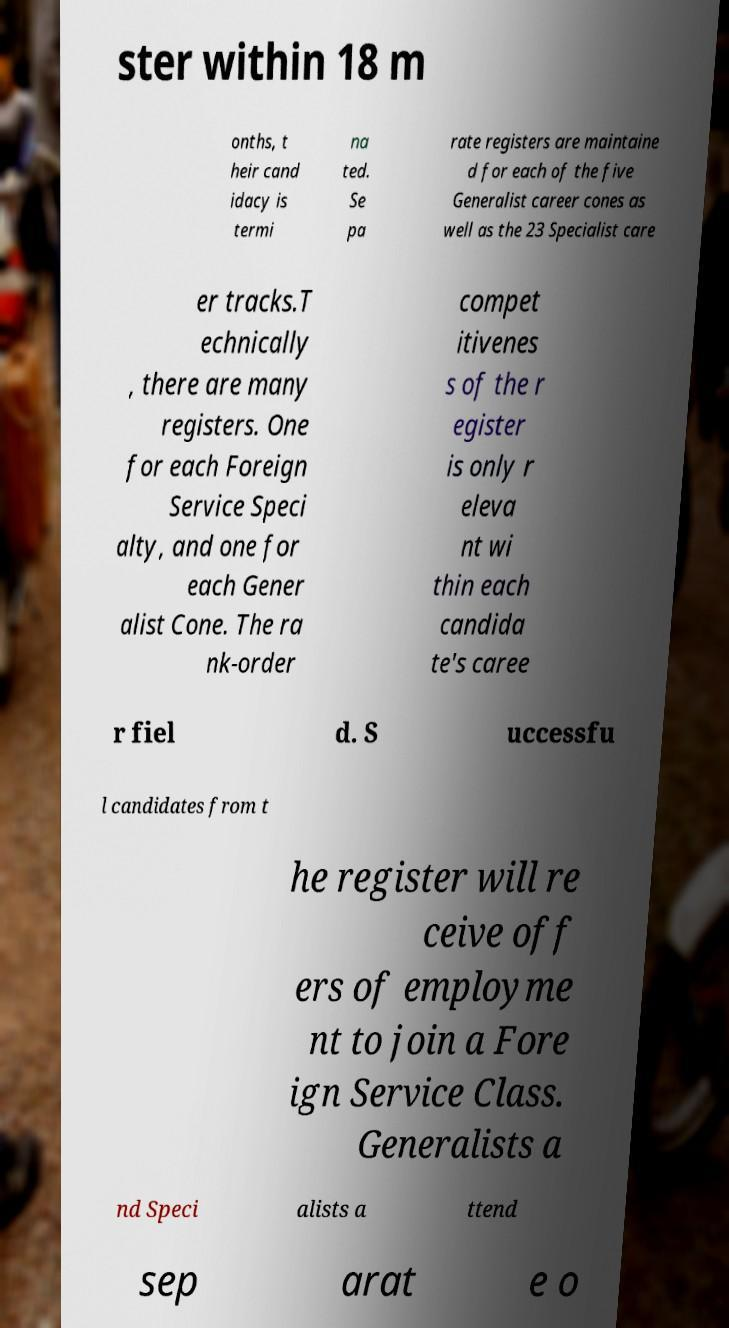Can you accurately transcribe the text from the provided image for me? ster within 18 m onths, t heir cand idacy is termi na ted. Se pa rate registers are maintaine d for each of the five Generalist career cones as well as the 23 Specialist care er tracks.T echnically , there are many registers. One for each Foreign Service Speci alty, and one for each Gener alist Cone. The ra nk-order compet itivenes s of the r egister is only r eleva nt wi thin each candida te's caree r fiel d. S uccessfu l candidates from t he register will re ceive off ers of employme nt to join a Fore ign Service Class. Generalists a nd Speci alists a ttend sep arat e o 